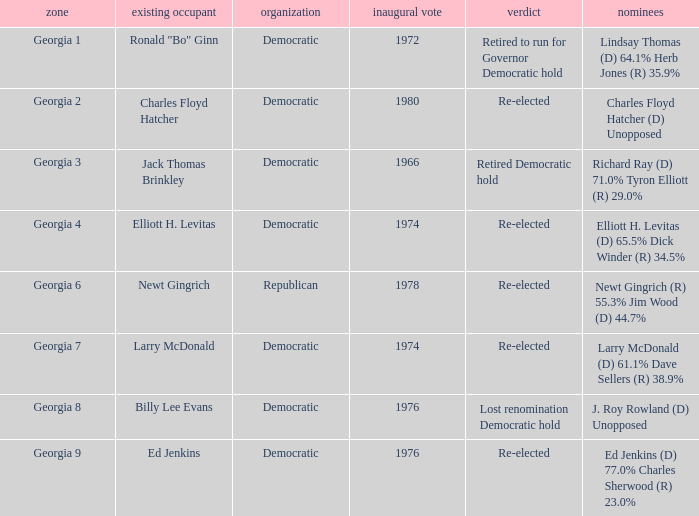Name the districk for larry mcdonald Georgia 7. 